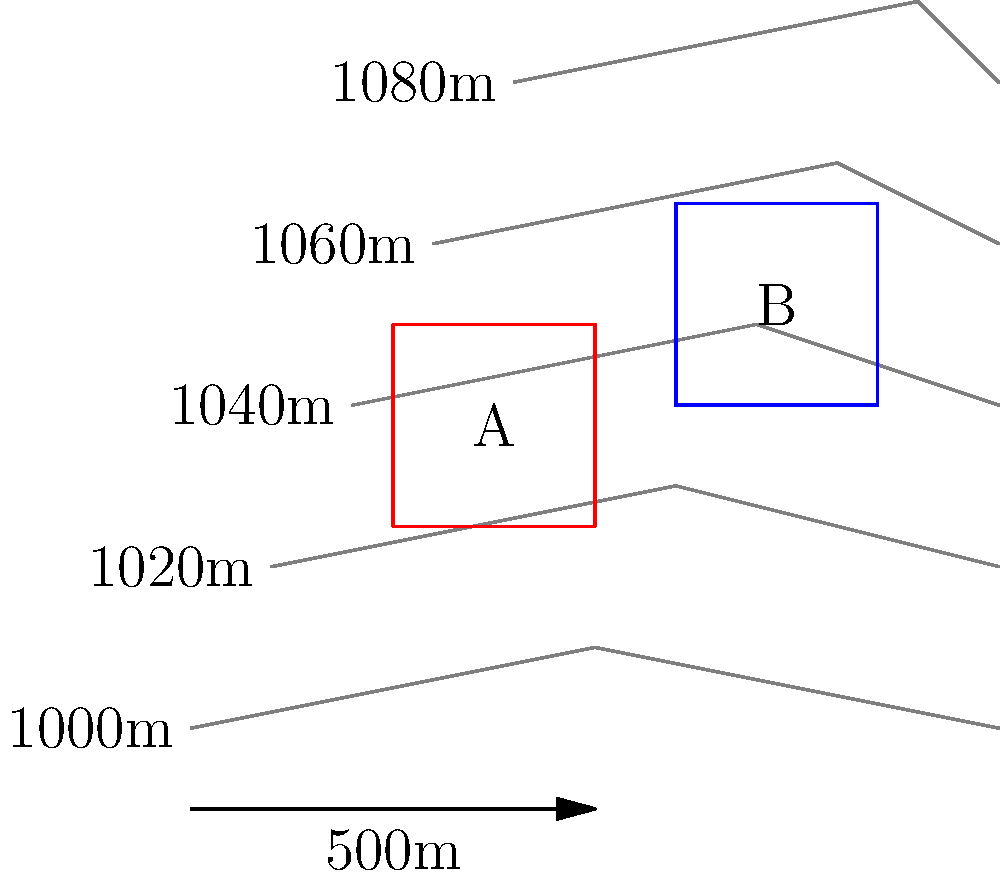Based on the topographical map provided, which of the two marked areas (A or B) is safer for dropping smokejumpers, considering that the minimum safe landing area should have a slope of less than 15%? Calculate the slope for both areas to justify your answer. To determine the safer landing area, we need to calculate the slope for both areas A and B. The slope can be calculated using the formula:

$$ \text{Slope} = \frac{\text{Rise}}{\text{Run}} \times 100\% $$

For Area A:
1. The area spans from approximately 1010m to 1030m elevation.
2. The horizontal distance (run) is about 500m (half the scale bar).
3. The vertical distance (rise) is 20m (1030m - 1010m).
4. Slope calculation:
   $$ \text{Slope}_A = \frac{20\text{m}}{500\text{m}} \times 100\% = 4\% $$

For Area B:
1. The area spans from approximately 1040m to 1060m elevation.
2. The horizontal distance (run) is about 500m (half the scale bar).
3. The vertical distance (rise) is 20m (1060m - 1040m).
4. Slope calculation:
   $$ \text{Slope}_B = \frac{20\text{m}}{500\text{m}} \times 100\% = 4\% $$

Both areas have the same slope of 4%, which is less than the maximum safe slope of 15%. However, Area A is at a lower elevation, which could be advantageous for smokejumpers in terms of air density and wind conditions.

Therefore, while both areas meet the slope requirement, Area A is slightly safer due to its lower elevation.
Answer: Area A, slope 4% 